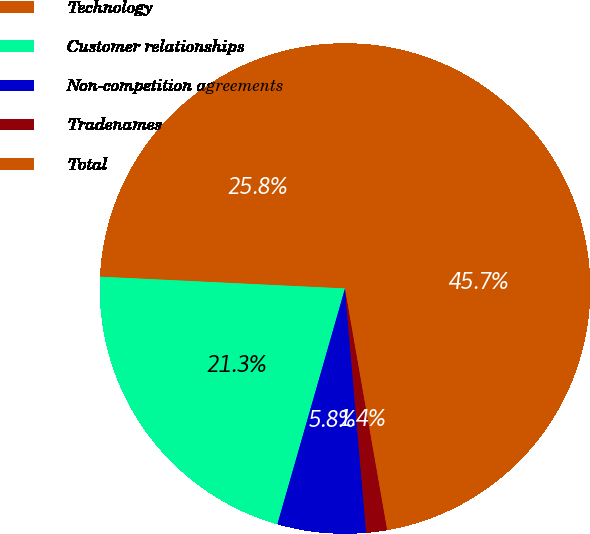<chart> <loc_0><loc_0><loc_500><loc_500><pie_chart><fcel>Technology<fcel>Customer relationships<fcel>Non-competition agreements<fcel>Tradenames<fcel>Total<nl><fcel>25.76%<fcel>21.32%<fcel>5.82%<fcel>1.38%<fcel>45.72%<nl></chart> 